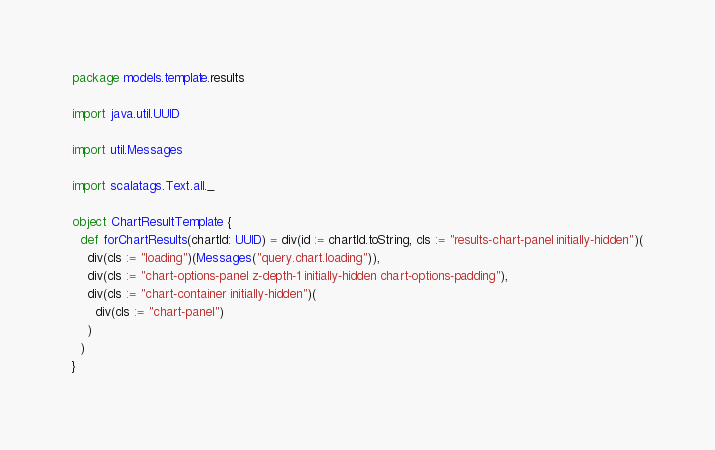<code> <loc_0><loc_0><loc_500><loc_500><_Scala_>package models.template.results

import java.util.UUID

import util.Messages

import scalatags.Text.all._

object ChartResultTemplate {
  def forChartResults(chartId: UUID) = div(id := chartId.toString, cls := "results-chart-panel initially-hidden")(
    div(cls := "loading")(Messages("query.chart.loading")),
    div(cls := "chart-options-panel z-depth-1 initially-hidden chart-options-padding"),
    div(cls := "chart-container initially-hidden")(
      div(cls := "chart-panel")
    )
  )
}
</code> 